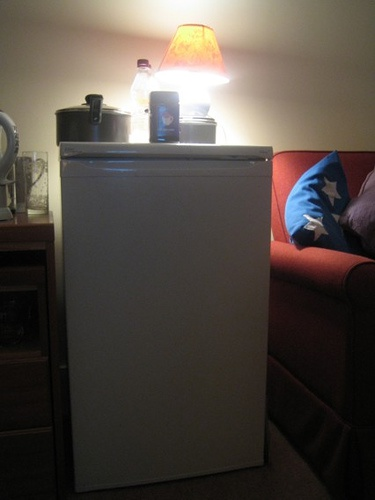Describe the objects in this image and their specific colors. I can see refrigerator in gray and black tones, couch in gray, black, maroon, and salmon tones, cup in gray and tan tones, and bottle in gray, white, darkgray, and pink tones in this image. 